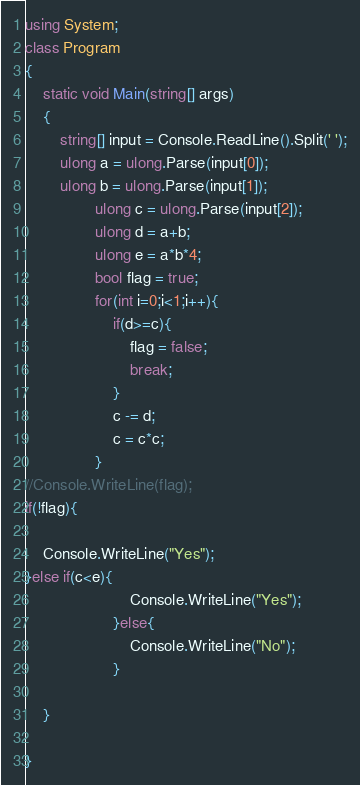Convert code to text. <code><loc_0><loc_0><loc_500><loc_500><_C#_>using System;
class Program
{
	static void Main(string[] args)
	{
		string[] input = Console.ReadLine().Split(' ');
        ulong a = ulong.Parse(input[0]);
        ulong b = ulong.Parse(input[1]);
				ulong c = ulong.Parse(input[2]);
				ulong d = a+b;
				ulong e = a*b*4;
				bool flag = true;
				for(int i=0;i<1;i++){
					if(d>=c){
						flag = false;
						break; 
					}
					c -= d;
					c = c*c;
				}
//Console.WriteLine(flag);
if(!flag){
    
	Console.WriteLine("Yes");
}else if(c<e){
						Console.WriteLine("Yes");
					}else{
						Console.WriteLine("No");
					}
				
	}

}
</code> 